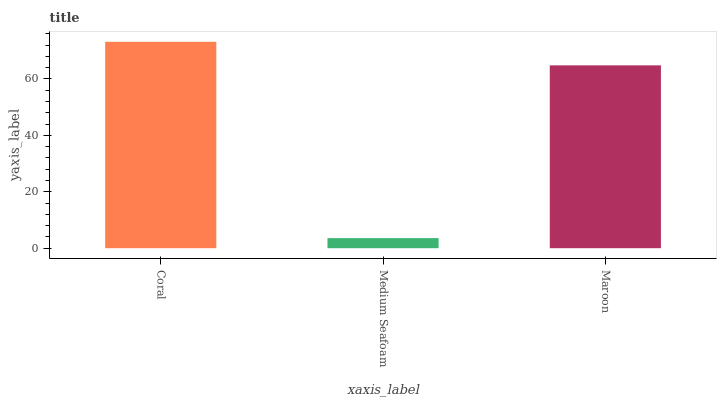Is Medium Seafoam the minimum?
Answer yes or no. Yes. Is Coral the maximum?
Answer yes or no. Yes. Is Maroon the minimum?
Answer yes or no. No. Is Maroon the maximum?
Answer yes or no. No. Is Maroon greater than Medium Seafoam?
Answer yes or no. Yes. Is Medium Seafoam less than Maroon?
Answer yes or no. Yes. Is Medium Seafoam greater than Maroon?
Answer yes or no. No. Is Maroon less than Medium Seafoam?
Answer yes or no. No. Is Maroon the high median?
Answer yes or no. Yes. Is Maroon the low median?
Answer yes or no. Yes. Is Coral the high median?
Answer yes or no. No. Is Medium Seafoam the low median?
Answer yes or no. No. 